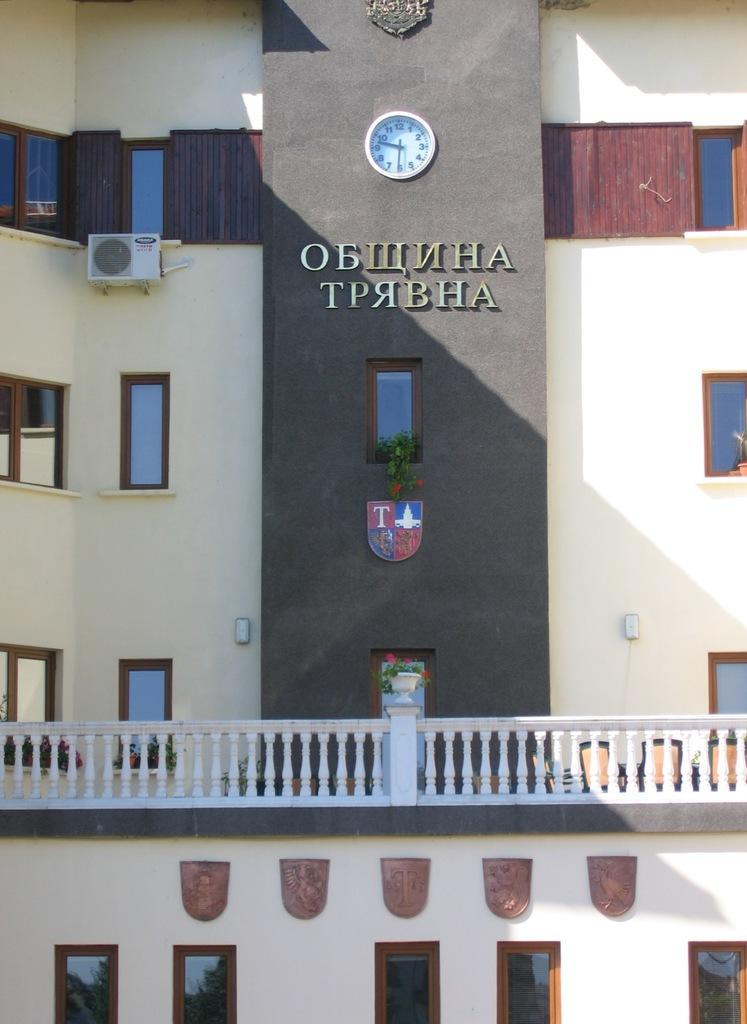In one or two sentences, can you explain what this image depicts? The picture consists of a building. At the bottom we can see windows, railing and flower pot. In the middle we can see plain, text and clock. On the left we can see windows and an air conditioner. 